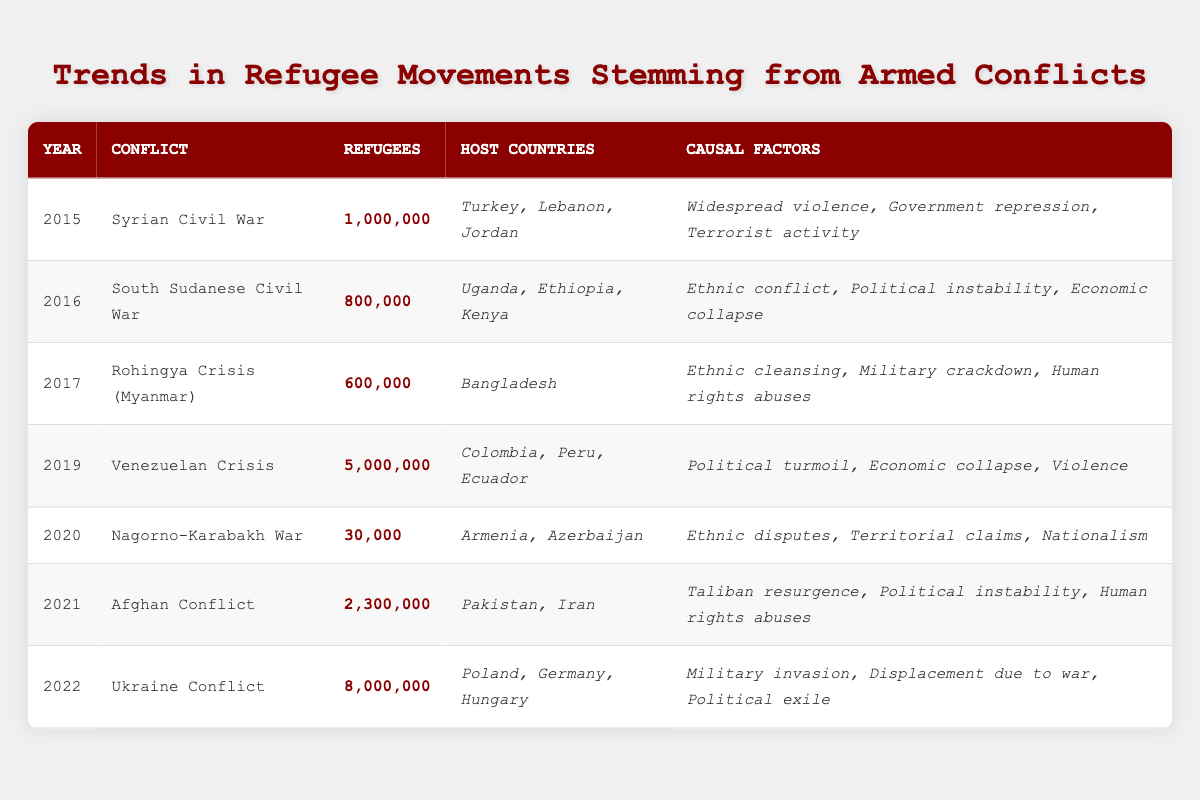What was the highest number of refugees recorded in a single year based on the table? The table shows that in 2019, the Venezuelan Crisis resulted in 5,000,000 refugees, which is the highest number listed across all years.
Answer: 5,000,000 In which year did the Afghan Conflict lead to 2,300,000 refugees? According to the table, the year associated with the Afghan Conflict having 2,300,000 refugees is 2021.
Answer: 2021 How many host countries were listed for the Rohingya Crisis? The table indicates that the Rohingya Crisis in Myanmar had only one host country, which is Bangladesh.
Answer: 1 What was the total number of refugees reported for the Syrian Civil War and the Afghan Conflict combined? To find this total, sum the refugees from both conflicts: 1,000,000 (Syrian Civil War) + 2,300,000 (Afghan Conflict) = 3,300,000.
Answer: 3,300,000 Did the Nagorno-Karabakh War result in more refugees than the South Sudanese Civil War? From the table, the Nagorno-Karabakh War had 30,000 refugees, while the South Sudanese Civil War had 800,000 refugees, so the statement is false.
Answer: No Which conflict had the largest number of causal factors listed? The Venezuelan Crisis had three causal factors, while others like the Nagorno-Karabakh War had only three, similarly, thus it's found that several conflicts had three factors. However, maximum mentioned in a single instance would indicate they are equally listed.
Answer: Equal What was the difference in the number of refugees between the Ukrainian Conflict and the Rohingya Crisis? The Ukrainian Conflict had 8,000,000 refugees while the Rohingya Crisis had 600,000 refugees; the difference is 8,000,000 - 600,000 = 7,400,000.
Answer: 7,400,000 Determine the average number of refugees across all conflicts listed in the table. The total number of refugees from all conflicts is 1,000,000 + 800,000 + 600,000 + 5,000,000 + 30,000 + 2,300,000 + 8,000,000 = 17,730,000. There are 7 conflicts, so the average is 17,730,000 / 7 ≈ 2,533,571.
Answer: 2,533,571 Which years had more than 1 million refugees? The years with more than 1 million refugees according to the table are 2015 (1,000,000), 2019 (5,000,000), 2021 (2,300,000), and 2022 (8,000,000).
Answer: 2019, 2021, 2022 What is the total number of refugees from conflicts in 2016 and 2017? The total number of refugees in 2016 is 800,000 and in 2017 is 600,000, therefore the combined total is 800,000 + 600,000 = 1,400,000.
Answer: 1,400,000 Did any conflict have 2 million or more refugees? Yes, the table indicates that both the Venezuelan Crisis and the Ukrainian Conflict reported 2,000,000 or more refugees.
Answer: Yes 